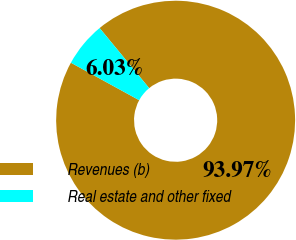Convert chart to OTSL. <chart><loc_0><loc_0><loc_500><loc_500><pie_chart><fcel>Revenues (b)<fcel>Real estate and other fixed<nl><fcel>93.97%<fcel>6.03%<nl></chart> 